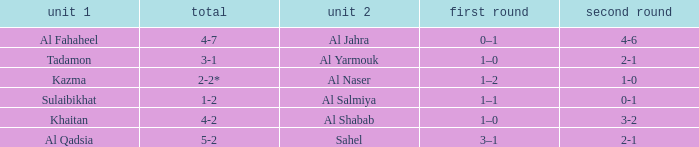What is the name of Team 2 with a 2nd leg of 4-6? Al Jahra. 